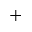<formula> <loc_0><loc_0><loc_500><loc_500>^ { + }</formula> 